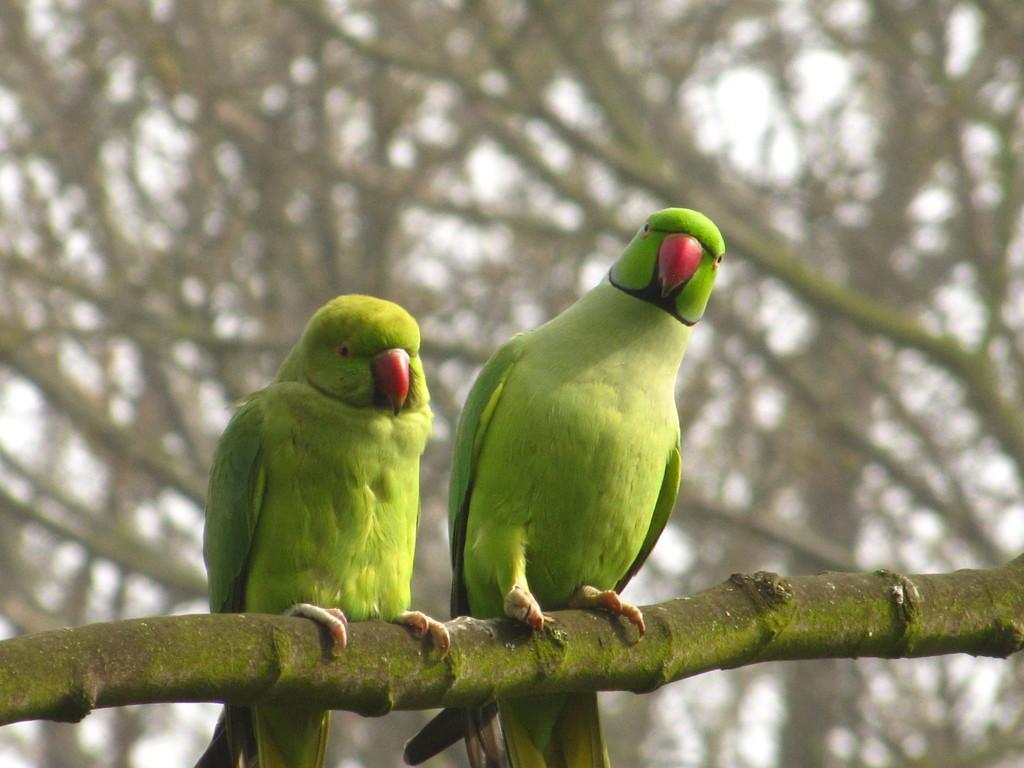How many parrots are in the image? There are two parrots in the image. Where are the parrots located? The parrots are on a branch. What can be seen in the background of the image? There is a bare tree and the sky visible in the background of the image. What type of competition are the parrots participating in within the image? There is no competition present in the image; the parrots are simply perched on a branch. 